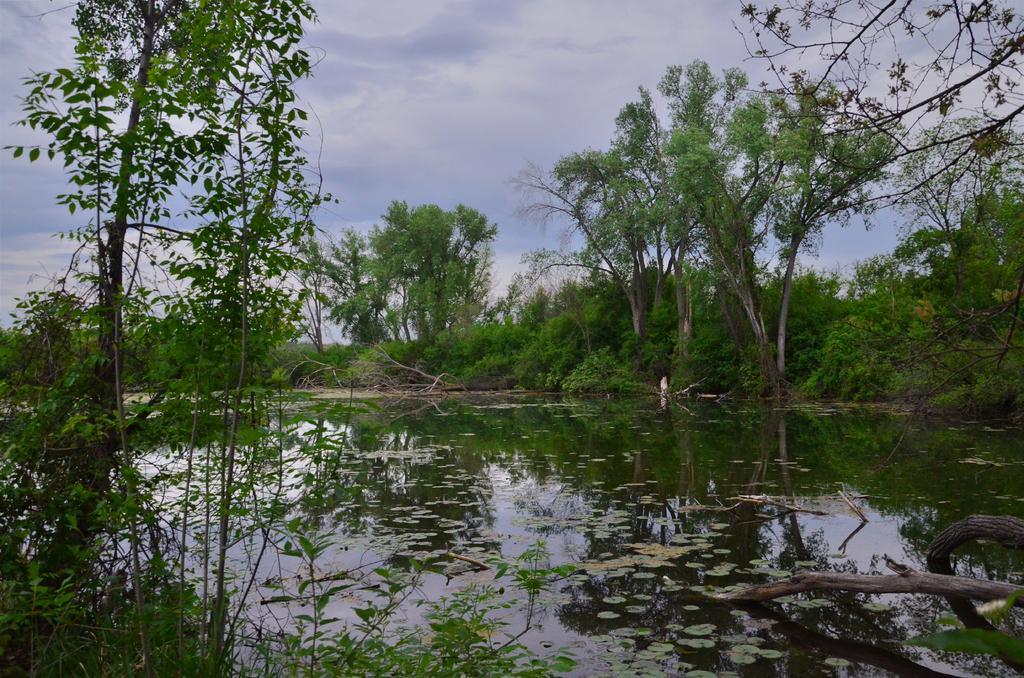Could you give a brief overview of what you see in this image? In this image we can see sky with clouds, trees, plants and leaves on the lake. 